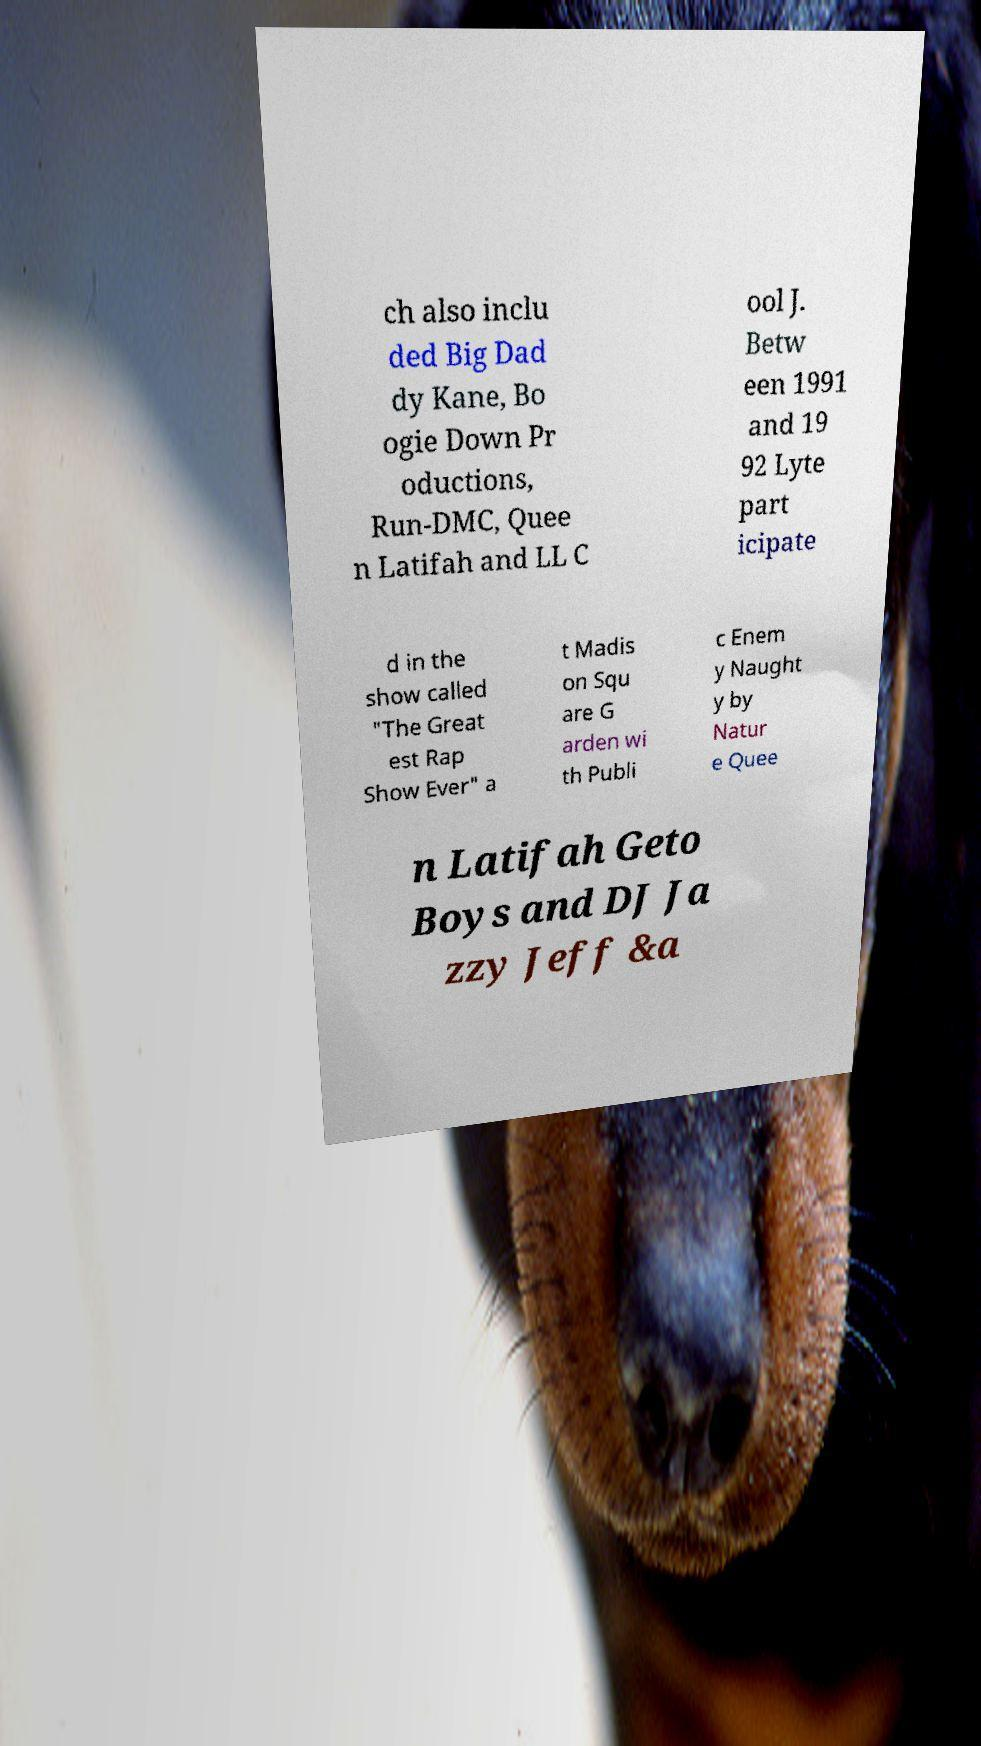Could you extract and type out the text from this image? ch also inclu ded Big Dad dy Kane, Bo ogie Down Pr oductions, Run-DMC, Quee n Latifah and LL C ool J. Betw een 1991 and 19 92 Lyte part icipate d in the show called "The Great est Rap Show Ever" a t Madis on Squ are G arden wi th Publi c Enem y Naught y by Natur e Quee n Latifah Geto Boys and DJ Ja zzy Jeff &a 